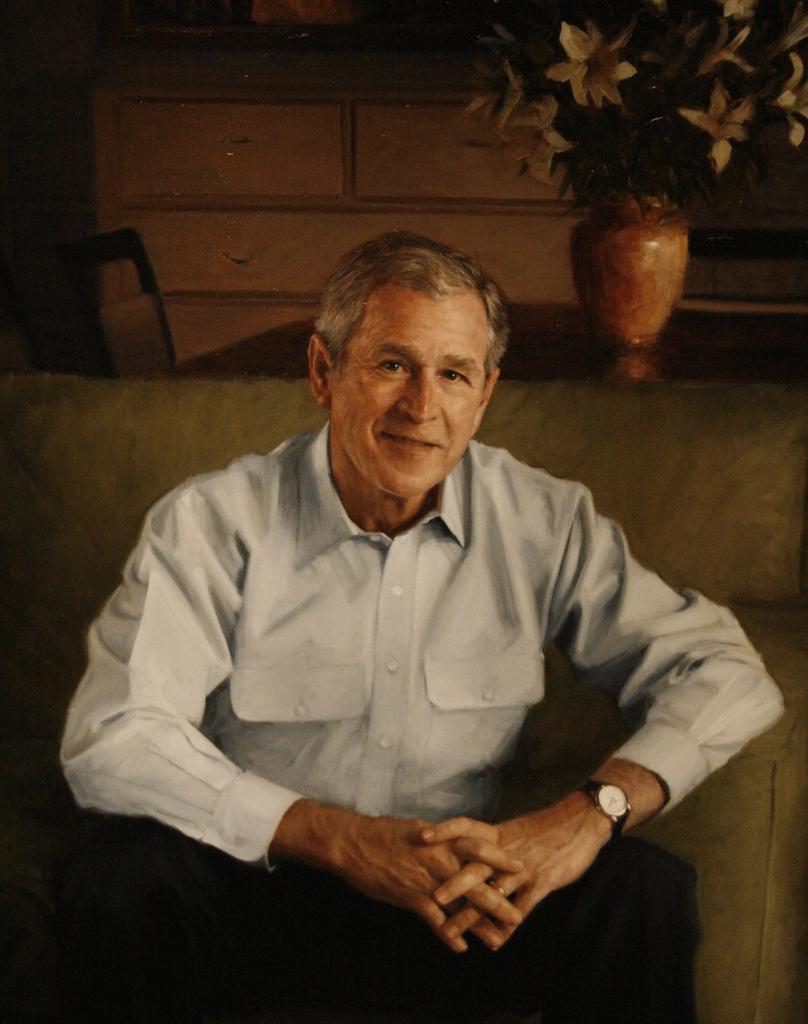Could you give a brief overview of what you see in this image? In this image we can see a person sitting and in the background there is a flower pot. 